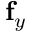Convert formula to latex. <formula><loc_0><loc_0><loc_500><loc_500>f _ { y }</formula> 